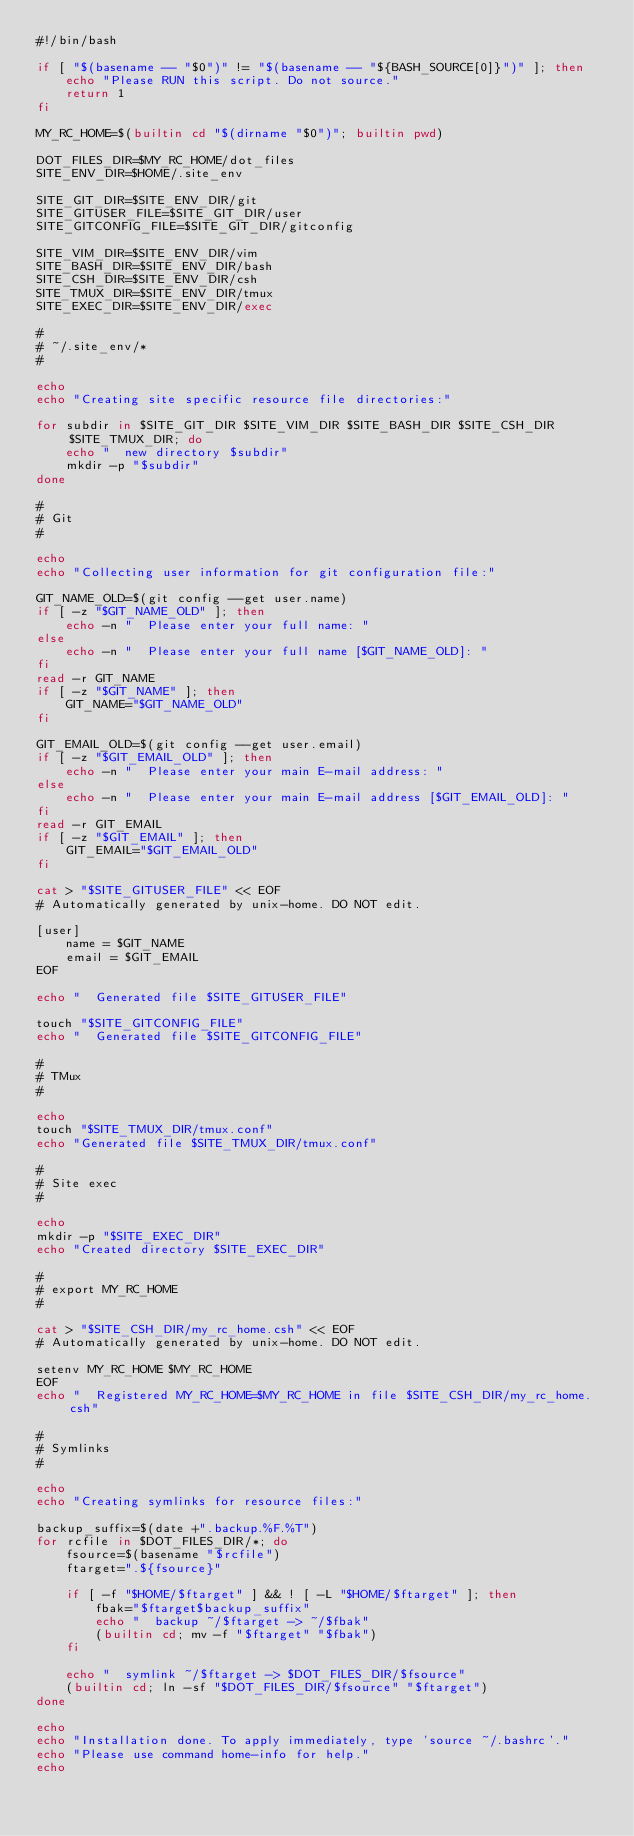Convert code to text. <code><loc_0><loc_0><loc_500><loc_500><_Bash_>#!/bin/bash

if [ "$(basename -- "$0")" != "$(basename -- "${BASH_SOURCE[0]}")" ]; then
    echo "Please RUN this script. Do not source."
    return 1
fi

MY_RC_HOME=$(builtin cd "$(dirname "$0")"; builtin pwd)

DOT_FILES_DIR=$MY_RC_HOME/dot_files
SITE_ENV_DIR=$HOME/.site_env

SITE_GIT_DIR=$SITE_ENV_DIR/git
SITE_GITUSER_FILE=$SITE_GIT_DIR/user
SITE_GITCONFIG_FILE=$SITE_GIT_DIR/gitconfig

SITE_VIM_DIR=$SITE_ENV_DIR/vim
SITE_BASH_DIR=$SITE_ENV_DIR/bash
SITE_CSH_DIR=$SITE_ENV_DIR/csh
SITE_TMUX_DIR=$SITE_ENV_DIR/tmux
SITE_EXEC_DIR=$SITE_ENV_DIR/exec

#
# ~/.site_env/*
#

echo
echo "Creating site specific resource file directories:"

for subdir in $SITE_GIT_DIR $SITE_VIM_DIR $SITE_BASH_DIR $SITE_CSH_DIR $SITE_TMUX_DIR; do
	echo "  new directory $subdir"
	mkdir -p "$subdir"
done

#
# Git
#

echo
echo "Collecting user information for git configuration file:"

GIT_NAME_OLD=$(git config --get user.name)
if [ -z "$GIT_NAME_OLD" ]; then
	echo -n "  Please enter your full name: "
else
	echo -n "  Please enter your full name [$GIT_NAME_OLD]: "
fi
read -r GIT_NAME
if [ -z "$GIT_NAME" ]; then
	GIT_NAME="$GIT_NAME_OLD"
fi

GIT_EMAIL_OLD=$(git config --get user.email)
if [ -z "$GIT_EMAIL_OLD" ]; then
	echo -n "  Please enter your main E-mail address: "
else
	echo -n "  Please enter your main E-mail address [$GIT_EMAIL_OLD]: "
fi
read -r GIT_EMAIL
if [ -z "$GIT_EMAIL" ]; then
	GIT_EMAIL="$GIT_EMAIL_OLD"
fi

cat > "$SITE_GITUSER_FILE" << EOF
# Automatically generated by unix-home. DO NOT edit.

[user]
	name = $GIT_NAME
	email = $GIT_EMAIL
EOF

echo "  Generated file $SITE_GITUSER_FILE"

touch "$SITE_GITCONFIG_FILE"
echo "  Generated file $SITE_GITCONFIG_FILE"

#
# TMux
#

echo
touch "$SITE_TMUX_DIR/tmux.conf"
echo "Generated file $SITE_TMUX_DIR/tmux.conf"

#
# Site exec
#

echo
mkdir -p "$SITE_EXEC_DIR"
echo "Created directory $SITE_EXEC_DIR"

#
# export MY_RC_HOME
#

cat > "$SITE_CSH_DIR/my_rc_home.csh" << EOF
# Automatically generated by unix-home. DO NOT edit.

setenv MY_RC_HOME $MY_RC_HOME
EOF
echo "  Registered MY_RC_HOME=$MY_RC_HOME in file $SITE_CSH_DIR/my_rc_home.csh"

#
# Symlinks
#

echo
echo "Creating symlinks for resource files:"

backup_suffix=$(date +".backup.%F.%T")
for rcfile in $DOT_FILES_DIR/*; do
    fsource=$(basename "$rcfile")
    ftarget=".${fsource}"

    if [ -f "$HOME/$ftarget" ] && ! [ -L "$HOME/$ftarget" ]; then
        fbak="$ftarget$backup_suffix"
        echo "  backup ~/$ftarget -> ~/$fbak"
        (builtin cd; mv -f "$ftarget" "$fbak")
    fi

	echo "  symlink ~/$ftarget -> $DOT_FILES_DIR/$fsource"
	(builtin cd; ln -sf "$DOT_FILES_DIR/$fsource" "$ftarget")
done

echo
echo "Installation done. To apply immediately, type 'source ~/.bashrc'."
echo "Please use command home-info for help."
echo
</code> 